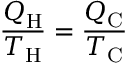Convert formula to latex. <formula><loc_0><loc_0><loc_500><loc_500>{ \frac { Q _ { H } } { T _ { H } } } = { \frac { Q _ { C } } { T _ { C } } }</formula> 